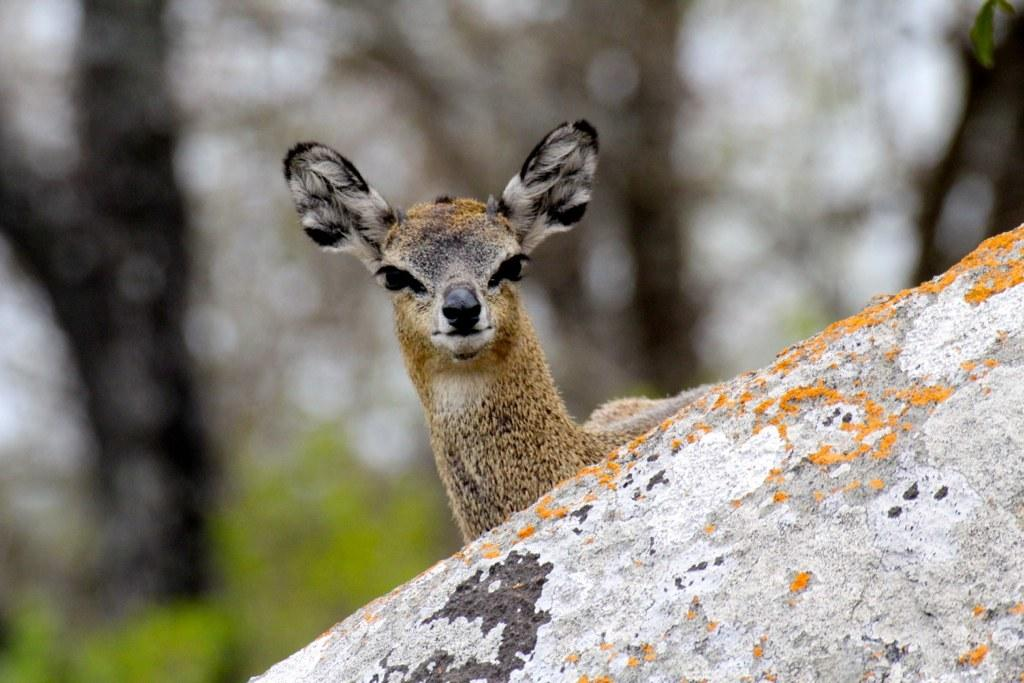What type of animal can be seen in the image? There is a white-tailed deer in the image. What other object is present in the image? There is a rock in the image. How many frogs can be seen hopping on the rock in the image? There are no frogs present in the image; it only features a white-tailed deer and a rock. 